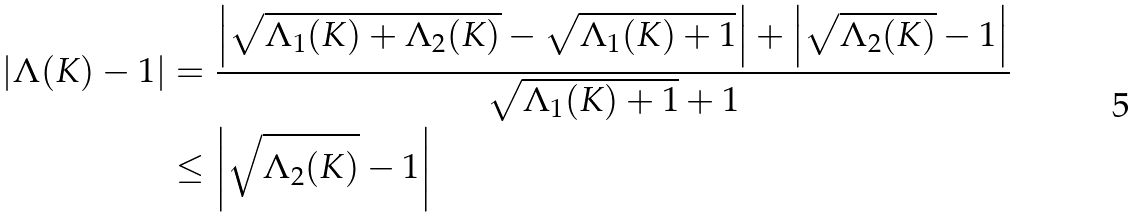Convert formula to latex. <formula><loc_0><loc_0><loc_500><loc_500>\left | \Lambda ( K ) - 1 \right | & = \frac { \left | \sqrt { \Lambda _ { 1 } ( K ) + \Lambda _ { 2 } ( K ) } - \sqrt { \Lambda _ { 1 } ( K ) + 1 } \right | + \left | \sqrt { \Lambda _ { 2 } ( K ) } - 1 \right | } { \sqrt { \Lambda _ { 1 } ( K ) + 1 } + 1 } \\ & \leq \left | \sqrt { \Lambda _ { 2 } ( K ) } - 1 \right |</formula> 